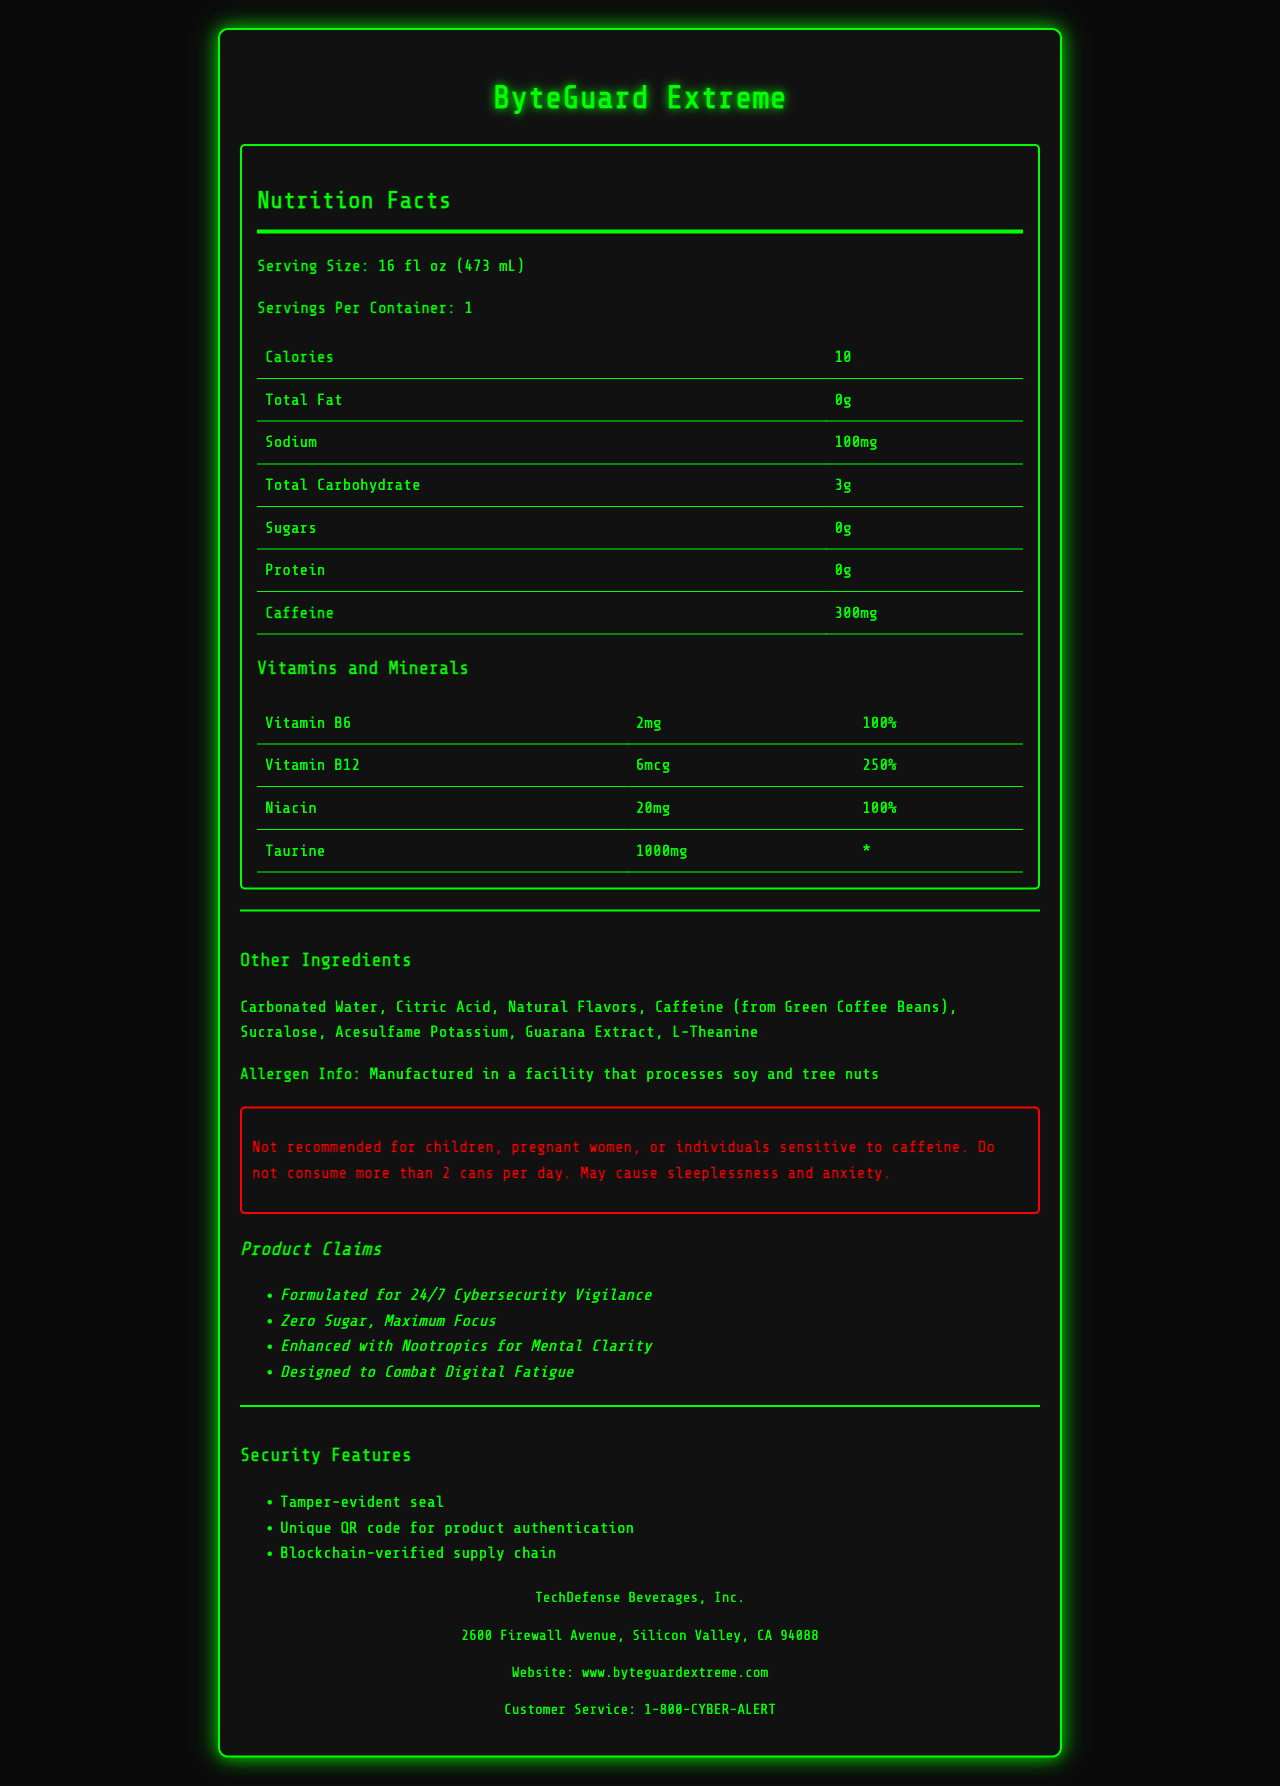what is the serving size of ByteGuard Extreme? The serving size is mentioned at the top of the Nutrition Facts section and states "Serving Size: 16 fl oz (473 mL)".
Answer: 16 fl oz (473 mL) How many calories are in one serving of ByteGuard Extreme? The document lists "Calories: 10" under the Nutrition Facts section for one serving.
Answer: 10 calories How much caffeine does one can of ByteGuard Extreme contain? The caffeine content is listed as "Caffeine: 300mg" in the Nutrition Facts table.
Answer: 300mg What is the percentage of Daily Value for Vitamin B12? The Nutrition Facts section includes a table with vitamins and minerals, showing "Vitamin B12: 250%" in the Daily Value column.
Answer: 250% List three key ingredients other than caffeine in ByteGuard Extreme. Under "Other Ingredients," the list includes Guarana Extract, L-Theanine, and Taurine among others.
Answer: Guarana Extract, L-Theanine, Taurine What is the sodium content per serving? The sodium content is listed in the Nutrition Facts table as "Sodium: 100mg".
Answer: 100mg Is this product recommended for children? The warning section explicitly states "Not recommended for children".
Answer: No  The document lists four marketing claims, and "Formulated for 24/7 Cybersecurity Vigilance" is one of them, while "All Natural Ingredients" and "Gluten-Free" are not mentioned.
Answer: II. Formulated for 24/7 Cybersecurity Vigilance ByteGuard Extreme includes a tamper-evident seal. Under the security features, "Tamper-evident seal" is listed as one of the security measures.
Answer: True What is the main idea of the Nutrition Facts Label for ByteGuard Extreme? The document primarily details the nutritional content, ingredients, warnings, marketing claims, security features, and company information for ByteGuard Extreme, emphasizing its focus on cybersecurity professionals.
Answer: ByteGuard Extreme is a high-caffeine energy drink designed for cybersecurity professionals, featuring various vitamins, nootropics, and security features, while being marketed for focus and digital fatigue. Who is the manufacturer of ByteGuard Extreme? The company info section at the bottom of the document states that the manufacturer is "TechDefense Beverages, Inc."
Answer: TechDefense Beverages, Inc. How many grams of fat are there in ByteGuard Extreme? The Nutrition Facts section lists "Total Fat: 0g".
Answer: 0g What is the daily value percentage for Niacin in ByteGuard Extreme? The Nutrition Facts section lists "Niacin: 100%" in the Daily Value column.
Answer: 100% Does this product contain sugar? The Nutrition Facts table lists "Sugars: 0g", indicating there is no sugar in the product.
Answer: No Which ingredient is not listed in the document? A. Carbonated Water B. Citric Acid C. Green Tea Extract D. Sucralose The document lists Carbonated Water, Citric Acid, and Sucralose among the ingredients, but Green Tea Extract is not mentioned.
Answer: C. Green Tea Extract Is ByteGuard Extreme suitable for individuals sensitive to caffeine? The warning section specifies "Not recommended for individuals sensitive to caffeine" due to its high caffeine content.
Answer: No How many servings are there per container? The section under serving info states "Servings Per Container: 1".
Answer: 1 What security feature ensures product authentication? The Security Features section lists "Unique QR code for product authentication" along with other features.
Answer: Unique QR code 